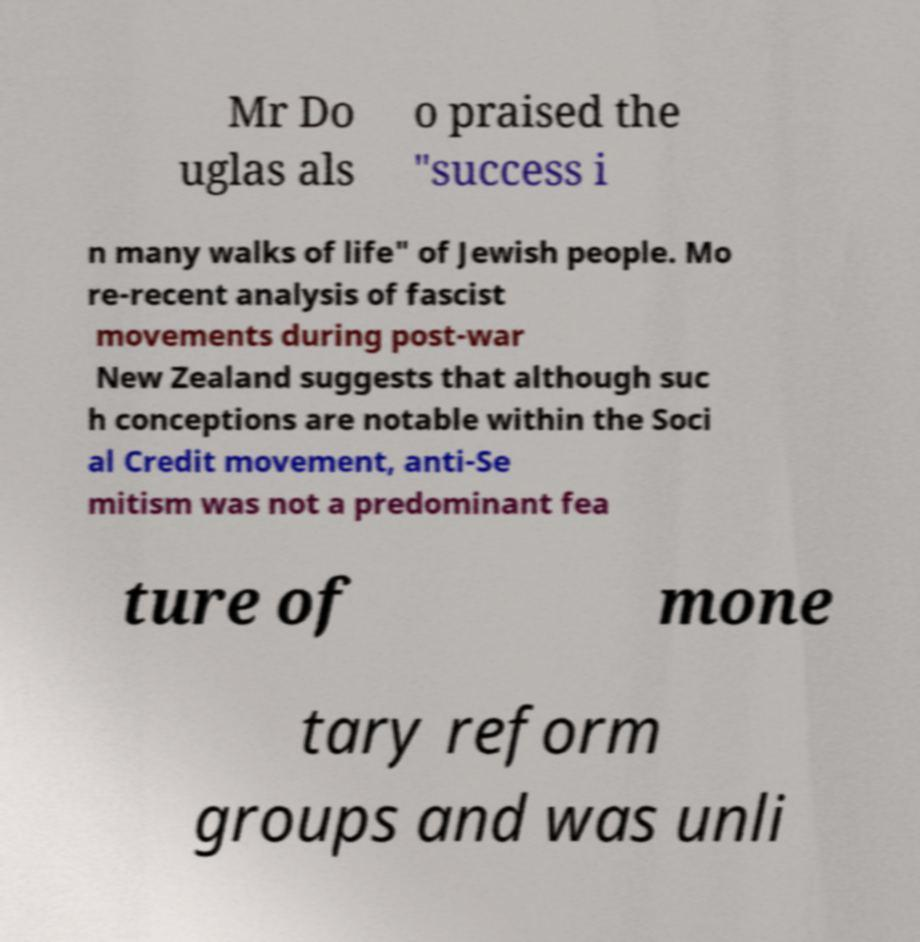Could you assist in decoding the text presented in this image and type it out clearly? Mr Do uglas als o praised the "success i n many walks of life" of Jewish people. Mo re-recent analysis of fascist movements during post-war New Zealand suggests that although suc h conceptions are notable within the Soci al Credit movement, anti-Se mitism was not a predominant fea ture of mone tary reform groups and was unli 